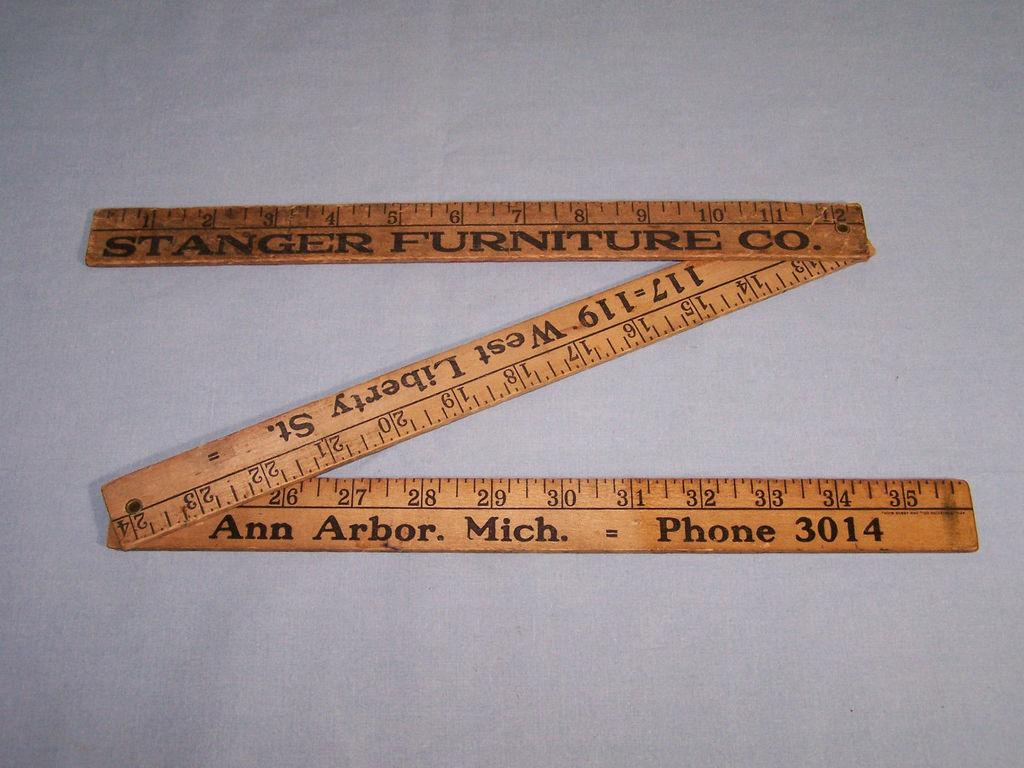Provide a one-sentence caption for the provided image. The Stranger Furniture Co. ruler will fold and unfold to three feet. 